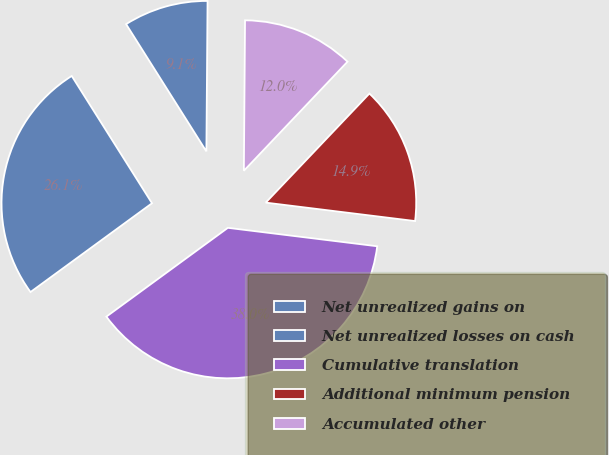Convert chart to OTSL. <chart><loc_0><loc_0><loc_500><loc_500><pie_chart><fcel>Net unrealized gains on<fcel>Net unrealized losses on cash<fcel>Cumulative translation<fcel>Additional minimum pension<fcel>Accumulated other<nl><fcel>9.08%<fcel>26.09%<fcel>38.0%<fcel>14.86%<fcel>11.97%<nl></chart> 